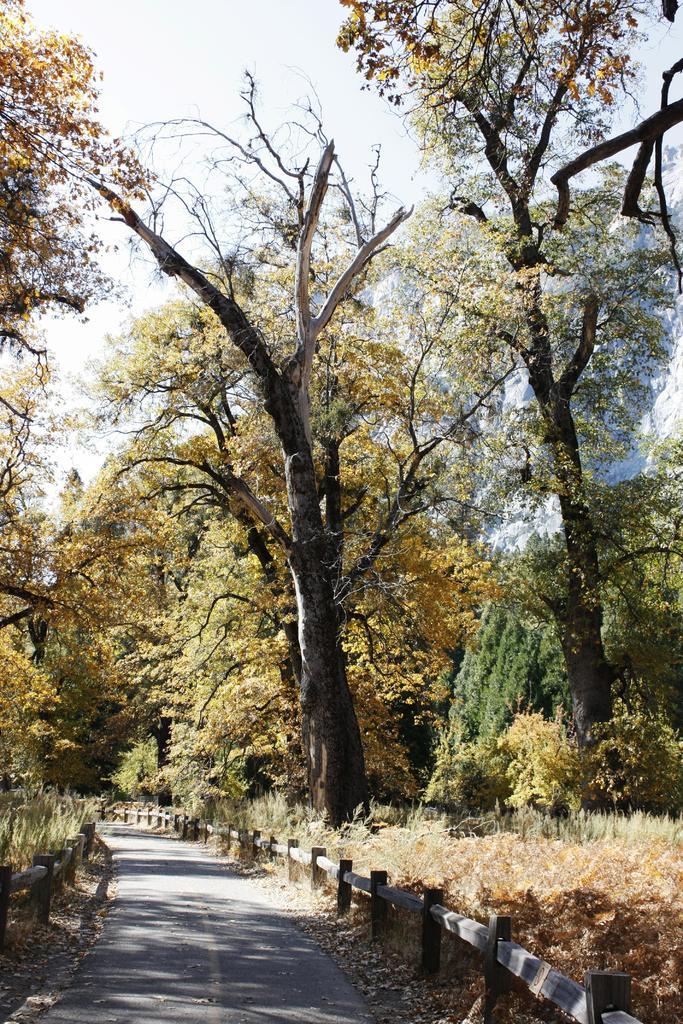Can you describe this image briefly? At the bottom of the image there is a road and we can see fences. In the background there are trees and sky. On the right there is grass. 